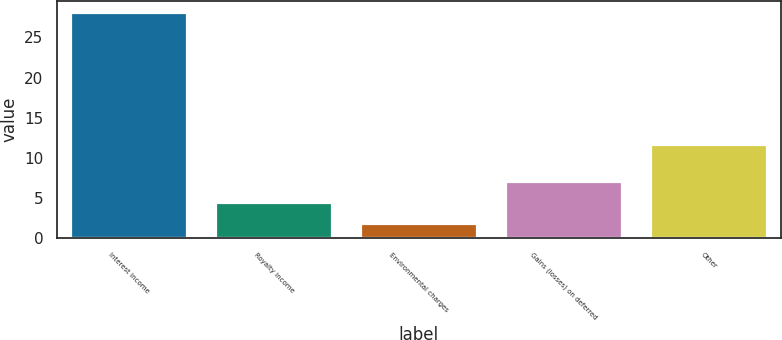Convert chart. <chart><loc_0><loc_0><loc_500><loc_500><bar_chart><fcel>Interest income<fcel>Royalty income<fcel>Environmental charges<fcel>Gains (losses) on deferred<fcel>Other<nl><fcel>28.1<fcel>4.34<fcel>1.7<fcel>6.98<fcel>11.6<nl></chart> 